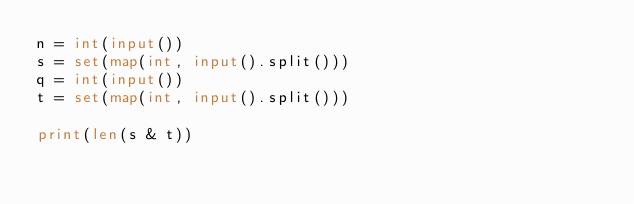<code> <loc_0><loc_0><loc_500><loc_500><_Python_>n = int(input())
s = set(map(int, input().split()))
q = int(input())
t = set(map(int, input().split()))

print(len(s & t))
</code> 